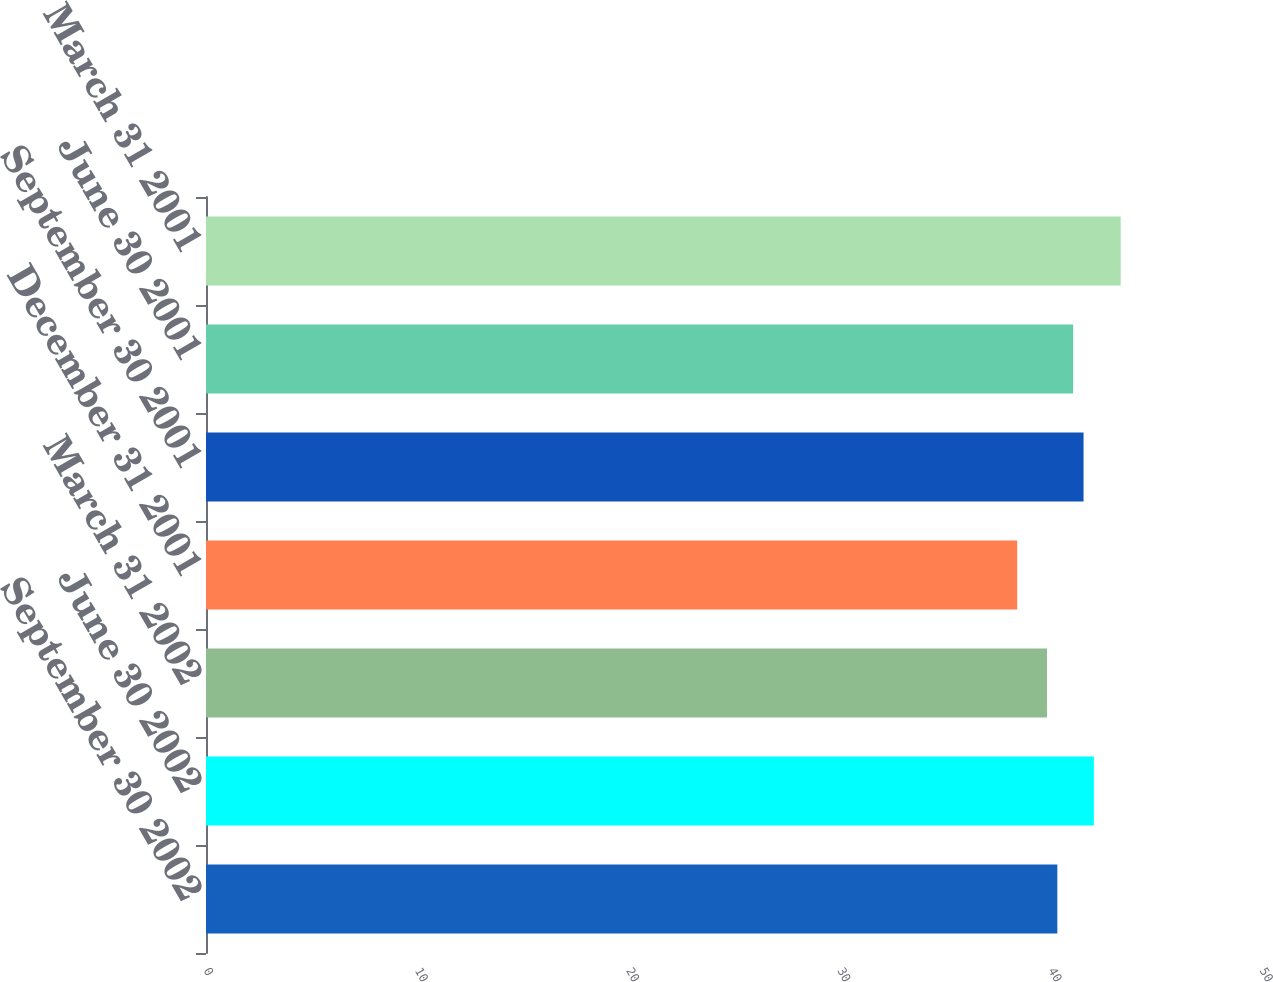<chart> <loc_0><loc_0><loc_500><loc_500><bar_chart><fcel>September 30 2002<fcel>June 30 2002<fcel>March 31 2002<fcel>December 31 2001<fcel>September 30 2001<fcel>June 30 2001<fcel>March 31 2001<nl><fcel>40.31<fcel>42.04<fcel>39.82<fcel>38.41<fcel>41.55<fcel>41.06<fcel>43.31<nl></chart> 